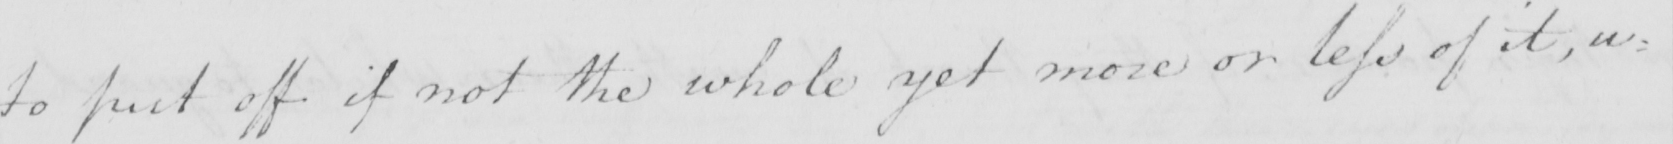What text is written in this handwritten line? to put off if not the whole yet more or less of it , u= 